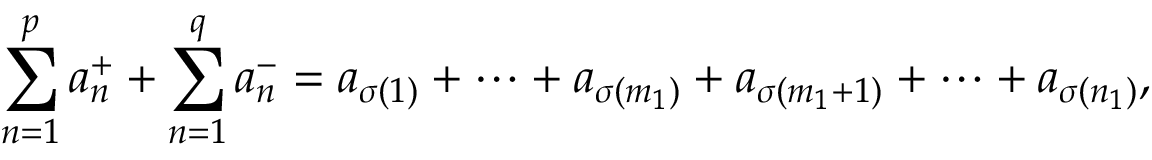<formula> <loc_0><loc_0><loc_500><loc_500>\sum _ { n = 1 } ^ { p } a _ { n } ^ { + } + \sum _ { n = 1 } ^ { q } a _ { n } ^ { - } = a _ { \sigma ( 1 ) } + \cdots + a _ { \sigma ( m _ { 1 } ) } + a _ { \sigma ( m _ { 1 } + 1 ) } + \cdots + a _ { \sigma ( n _ { 1 } ) } ,</formula> 